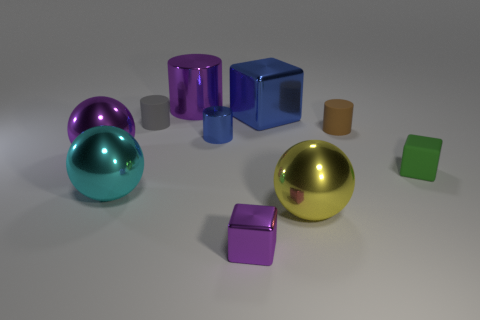Subtract all purple cylinders. How many cylinders are left? 3 Subtract all purple cylinders. How many cylinders are left? 3 Subtract all cylinders. How many objects are left? 6 Subtract all gray spheres. Subtract all small purple cubes. How many objects are left? 9 Add 6 big purple metallic balls. How many big purple metallic balls are left? 7 Add 5 large cylinders. How many large cylinders exist? 6 Subtract 0 brown blocks. How many objects are left? 10 Subtract 1 blocks. How many blocks are left? 2 Subtract all brown cylinders. Subtract all gray balls. How many cylinders are left? 3 